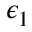Convert formula to latex. <formula><loc_0><loc_0><loc_500><loc_500>\epsilon _ { 1 }</formula> 